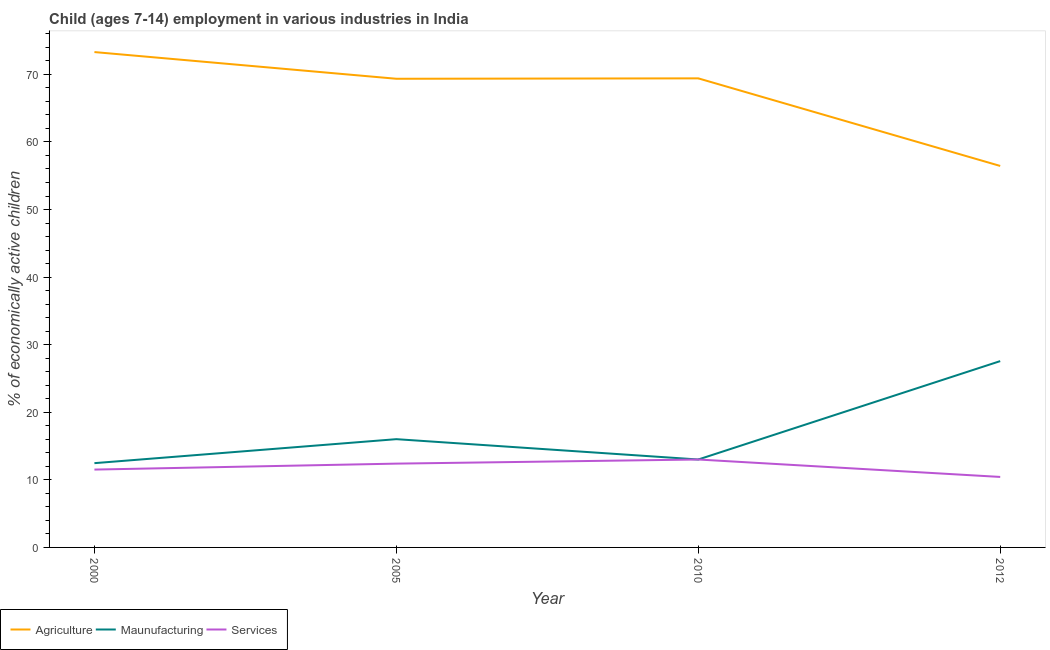How many different coloured lines are there?
Provide a short and direct response. 3. Does the line corresponding to percentage of economically active children in manufacturing intersect with the line corresponding to percentage of economically active children in agriculture?
Your answer should be compact. No. What is the percentage of economically active children in manufacturing in 2010?
Keep it short and to the point. 13.01. Across all years, what is the maximum percentage of economically active children in services?
Ensure brevity in your answer.  13.01. Across all years, what is the minimum percentage of economically active children in services?
Offer a terse response. 10.43. In which year was the percentage of economically active children in services maximum?
Your response must be concise. 2010. In which year was the percentage of economically active children in agriculture minimum?
Give a very brief answer. 2012. What is the total percentage of economically active children in services in the graph?
Ensure brevity in your answer.  47.36. What is the difference between the percentage of economically active children in manufacturing in 2000 and that in 2005?
Give a very brief answer. -3.55. What is the difference between the percentage of economically active children in manufacturing in 2010 and the percentage of economically active children in agriculture in 2012?
Offer a terse response. -43.44. What is the average percentage of economically active children in manufacturing per year?
Keep it short and to the point. 17.27. In the year 2005, what is the difference between the percentage of economically active children in manufacturing and percentage of economically active children in agriculture?
Your answer should be compact. -53.33. In how many years, is the percentage of economically active children in services greater than 52 %?
Offer a very short reply. 0. What is the ratio of the percentage of economically active children in services in 2005 to that in 2012?
Your answer should be very brief. 1.19. What is the difference between the highest and the second highest percentage of economically active children in services?
Offer a very short reply. 0.61. What is the difference between the highest and the lowest percentage of economically active children in services?
Keep it short and to the point. 2.58. In how many years, is the percentage of economically active children in services greater than the average percentage of economically active children in services taken over all years?
Keep it short and to the point. 2. Does the percentage of economically active children in services monotonically increase over the years?
Provide a short and direct response. No. Is the percentage of economically active children in manufacturing strictly greater than the percentage of economically active children in services over the years?
Provide a short and direct response. No. How many lines are there?
Make the answer very short. 3. Are the values on the major ticks of Y-axis written in scientific E-notation?
Keep it short and to the point. No. Does the graph contain grids?
Keep it short and to the point. No. Where does the legend appear in the graph?
Provide a succinct answer. Bottom left. How many legend labels are there?
Ensure brevity in your answer.  3. How are the legend labels stacked?
Give a very brief answer. Horizontal. What is the title of the graph?
Provide a short and direct response. Child (ages 7-14) employment in various industries in India. Does "Infant(male)" appear as one of the legend labels in the graph?
Offer a very short reply. No. What is the label or title of the X-axis?
Ensure brevity in your answer.  Year. What is the label or title of the Y-axis?
Provide a succinct answer. % of economically active children. What is the % of economically active children of Agriculture in 2000?
Offer a very short reply. 73.3. What is the % of economically active children of Maunufacturing in 2000?
Your answer should be very brief. 12.47. What is the % of economically active children in Services in 2000?
Provide a short and direct response. 11.52. What is the % of economically active children of Agriculture in 2005?
Offer a very short reply. 69.35. What is the % of economically active children in Maunufacturing in 2005?
Provide a short and direct response. 16.02. What is the % of economically active children in Agriculture in 2010?
Offer a terse response. 69.41. What is the % of economically active children in Maunufacturing in 2010?
Make the answer very short. 13.01. What is the % of economically active children of Services in 2010?
Your answer should be very brief. 13.01. What is the % of economically active children in Agriculture in 2012?
Provide a succinct answer. 56.45. What is the % of economically active children of Maunufacturing in 2012?
Your answer should be compact. 27.57. What is the % of economically active children in Services in 2012?
Offer a terse response. 10.43. Across all years, what is the maximum % of economically active children of Agriculture?
Your answer should be compact. 73.3. Across all years, what is the maximum % of economically active children of Maunufacturing?
Provide a short and direct response. 27.57. Across all years, what is the maximum % of economically active children of Services?
Make the answer very short. 13.01. Across all years, what is the minimum % of economically active children in Agriculture?
Give a very brief answer. 56.45. Across all years, what is the minimum % of economically active children in Maunufacturing?
Provide a short and direct response. 12.47. Across all years, what is the minimum % of economically active children of Services?
Keep it short and to the point. 10.43. What is the total % of economically active children in Agriculture in the graph?
Keep it short and to the point. 268.51. What is the total % of economically active children in Maunufacturing in the graph?
Provide a short and direct response. 69.07. What is the total % of economically active children in Services in the graph?
Offer a terse response. 47.36. What is the difference between the % of economically active children in Agriculture in 2000 and that in 2005?
Provide a short and direct response. 3.95. What is the difference between the % of economically active children in Maunufacturing in 2000 and that in 2005?
Ensure brevity in your answer.  -3.55. What is the difference between the % of economically active children of Services in 2000 and that in 2005?
Give a very brief answer. -0.88. What is the difference between the % of economically active children in Agriculture in 2000 and that in 2010?
Keep it short and to the point. 3.89. What is the difference between the % of economically active children in Maunufacturing in 2000 and that in 2010?
Make the answer very short. -0.54. What is the difference between the % of economically active children in Services in 2000 and that in 2010?
Make the answer very short. -1.49. What is the difference between the % of economically active children of Agriculture in 2000 and that in 2012?
Provide a succinct answer. 16.85. What is the difference between the % of economically active children of Maunufacturing in 2000 and that in 2012?
Your answer should be compact. -15.1. What is the difference between the % of economically active children in Services in 2000 and that in 2012?
Your answer should be very brief. 1.09. What is the difference between the % of economically active children of Agriculture in 2005 and that in 2010?
Make the answer very short. -0.06. What is the difference between the % of economically active children of Maunufacturing in 2005 and that in 2010?
Your response must be concise. 3.01. What is the difference between the % of economically active children of Services in 2005 and that in 2010?
Provide a succinct answer. -0.61. What is the difference between the % of economically active children in Agriculture in 2005 and that in 2012?
Ensure brevity in your answer.  12.9. What is the difference between the % of economically active children of Maunufacturing in 2005 and that in 2012?
Offer a very short reply. -11.55. What is the difference between the % of economically active children in Services in 2005 and that in 2012?
Your response must be concise. 1.97. What is the difference between the % of economically active children of Agriculture in 2010 and that in 2012?
Offer a terse response. 12.96. What is the difference between the % of economically active children in Maunufacturing in 2010 and that in 2012?
Ensure brevity in your answer.  -14.56. What is the difference between the % of economically active children of Services in 2010 and that in 2012?
Keep it short and to the point. 2.58. What is the difference between the % of economically active children of Agriculture in 2000 and the % of economically active children of Maunufacturing in 2005?
Provide a succinct answer. 57.28. What is the difference between the % of economically active children of Agriculture in 2000 and the % of economically active children of Services in 2005?
Make the answer very short. 60.9. What is the difference between the % of economically active children in Maunufacturing in 2000 and the % of economically active children in Services in 2005?
Your answer should be compact. 0.07. What is the difference between the % of economically active children in Agriculture in 2000 and the % of economically active children in Maunufacturing in 2010?
Make the answer very short. 60.29. What is the difference between the % of economically active children in Agriculture in 2000 and the % of economically active children in Services in 2010?
Provide a succinct answer. 60.29. What is the difference between the % of economically active children of Maunufacturing in 2000 and the % of economically active children of Services in 2010?
Ensure brevity in your answer.  -0.54. What is the difference between the % of economically active children of Agriculture in 2000 and the % of economically active children of Maunufacturing in 2012?
Ensure brevity in your answer.  45.73. What is the difference between the % of economically active children in Agriculture in 2000 and the % of economically active children in Services in 2012?
Offer a very short reply. 62.87. What is the difference between the % of economically active children in Maunufacturing in 2000 and the % of economically active children in Services in 2012?
Give a very brief answer. 2.04. What is the difference between the % of economically active children of Agriculture in 2005 and the % of economically active children of Maunufacturing in 2010?
Your answer should be compact. 56.34. What is the difference between the % of economically active children in Agriculture in 2005 and the % of economically active children in Services in 2010?
Make the answer very short. 56.34. What is the difference between the % of economically active children of Maunufacturing in 2005 and the % of economically active children of Services in 2010?
Make the answer very short. 3.01. What is the difference between the % of economically active children of Agriculture in 2005 and the % of economically active children of Maunufacturing in 2012?
Give a very brief answer. 41.78. What is the difference between the % of economically active children of Agriculture in 2005 and the % of economically active children of Services in 2012?
Your answer should be very brief. 58.92. What is the difference between the % of economically active children of Maunufacturing in 2005 and the % of economically active children of Services in 2012?
Ensure brevity in your answer.  5.59. What is the difference between the % of economically active children in Agriculture in 2010 and the % of economically active children in Maunufacturing in 2012?
Offer a terse response. 41.84. What is the difference between the % of economically active children of Agriculture in 2010 and the % of economically active children of Services in 2012?
Provide a succinct answer. 58.98. What is the difference between the % of economically active children of Maunufacturing in 2010 and the % of economically active children of Services in 2012?
Ensure brevity in your answer.  2.58. What is the average % of economically active children in Agriculture per year?
Your response must be concise. 67.13. What is the average % of economically active children in Maunufacturing per year?
Offer a very short reply. 17.27. What is the average % of economically active children in Services per year?
Offer a very short reply. 11.84. In the year 2000, what is the difference between the % of economically active children of Agriculture and % of economically active children of Maunufacturing?
Your response must be concise. 60.83. In the year 2000, what is the difference between the % of economically active children of Agriculture and % of economically active children of Services?
Your answer should be compact. 61.78. In the year 2000, what is the difference between the % of economically active children in Maunufacturing and % of economically active children in Services?
Provide a short and direct response. 0.95. In the year 2005, what is the difference between the % of economically active children in Agriculture and % of economically active children in Maunufacturing?
Offer a terse response. 53.33. In the year 2005, what is the difference between the % of economically active children in Agriculture and % of economically active children in Services?
Give a very brief answer. 56.95. In the year 2005, what is the difference between the % of economically active children of Maunufacturing and % of economically active children of Services?
Make the answer very short. 3.62. In the year 2010, what is the difference between the % of economically active children in Agriculture and % of economically active children in Maunufacturing?
Your answer should be compact. 56.4. In the year 2010, what is the difference between the % of economically active children in Agriculture and % of economically active children in Services?
Offer a terse response. 56.4. In the year 2012, what is the difference between the % of economically active children of Agriculture and % of economically active children of Maunufacturing?
Your response must be concise. 28.88. In the year 2012, what is the difference between the % of economically active children of Agriculture and % of economically active children of Services?
Give a very brief answer. 46.02. In the year 2012, what is the difference between the % of economically active children of Maunufacturing and % of economically active children of Services?
Your response must be concise. 17.14. What is the ratio of the % of economically active children in Agriculture in 2000 to that in 2005?
Your response must be concise. 1.06. What is the ratio of the % of economically active children in Maunufacturing in 2000 to that in 2005?
Give a very brief answer. 0.78. What is the ratio of the % of economically active children of Services in 2000 to that in 2005?
Your answer should be very brief. 0.93. What is the ratio of the % of economically active children of Agriculture in 2000 to that in 2010?
Provide a short and direct response. 1.06. What is the ratio of the % of economically active children of Maunufacturing in 2000 to that in 2010?
Provide a short and direct response. 0.96. What is the ratio of the % of economically active children of Services in 2000 to that in 2010?
Your answer should be compact. 0.89. What is the ratio of the % of economically active children in Agriculture in 2000 to that in 2012?
Your answer should be compact. 1.3. What is the ratio of the % of economically active children of Maunufacturing in 2000 to that in 2012?
Your response must be concise. 0.45. What is the ratio of the % of economically active children in Services in 2000 to that in 2012?
Your answer should be very brief. 1.1. What is the ratio of the % of economically active children in Agriculture in 2005 to that in 2010?
Offer a very short reply. 1. What is the ratio of the % of economically active children of Maunufacturing in 2005 to that in 2010?
Make the answer very short. 1.23. What is the ratio of the % of economically active children in Services in 2005 to that in 2010?
Ensure brevity in your answer.  0.95. What is the ratio of the % of economically active children in Agriculture in 2005 to that in 2012?
Offer a terse response. 1.23. What is the ratio of the % of economically active children in Maunufacturing in 2005 to that in 2012?
Offer a very short reply. 0.58. What is the ratio of the % of economically active children of Services in 2005 to that in 2012?
Your response must be concise. 1.19. What is the ratio of the % of economically active children of Agriculture in 2010 to that in 2012?
Make the answer very short. 1.23. What is the ratio of the % of economically active children in Maunufacturing in 2010 to that in 2012?
Make the answer very short. 0.47. What is the ratio of the % of economically active children in Services in 2010 to that in 2012?
Offer a terse response. 1.25. What is the difference between the highest and the second highest % of economically active children in Agriculture?
Provide a succinct answer. 3.89. What is the difference between the highest and the second highest % of economically active children in Maunufacturing?
Your answer should be very brief. 11.55. What is the difference between the highest and the second highest % of economically active children in Services?
Your answer should be compact. 0.61. What is the difference between the highest and the lowest % of economically active children of Agriculture?
Your answer should be compact. 16.85. What is the difference between the highest and the lowest % of economically active children in Services?
Give a very brief answer. 2.58. 